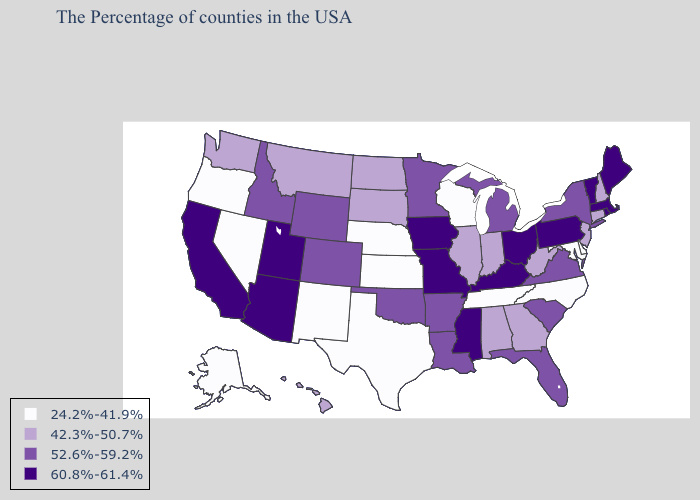What is the value of Michigan?
Answer briefly. 52.6%-59.2%. Name the states that have a value in the range 60.8%-61.4%?
Concise answer only. Maine, Massachusetts, Rhode Island, Vermont, Pennsylvania, Ohio, Kentucky, Mississippi, Missouri, Iowa, Utah, Arizona, California. Does Colorado have a lower value than Arizona?
Write a very short answer. Yes. What is the highest value in states that border Massachusetts?
Be succinct. 60.8%-61.4%. Does Idaho have the lowest value in the USA?
Give a very brief answer. No. What is the value of New Jersey?
Answer briefly. 42.3%-50.7%. Name the states that have a value in the range 42.3%-50.7%?
Be succinct. New Hampshire, Connecticut, New Jersey, West Virginia, Georgia, Indiana, Alabama, Illinois, South Dakota, North Dakota, Montana, Washington, Hawaii. What is the value of Rhode Island?
Write a very short answer. 60.8%-61.4%. Does Vermont have a lower value than Kansas?
Keep it brief. No. What is the lowest value in states that border Kansas?
Quick response, please. 24.2%-41.9%. Does Nebraska have a lower value than Florida?
Write a very short answer. Yes. What is the value of Georgia?
Concise answer only. 42.3%-50.7%. What is the value of Wisconsin?
Give a very brief answer. 24.2%-41.9%. What is the value of Indiana?
Quick response, please. 42.3%-50.7%. Which states have the lowest value in the MidWest?
Short answer required. Wisconsin, Kansas, Nebraska. 